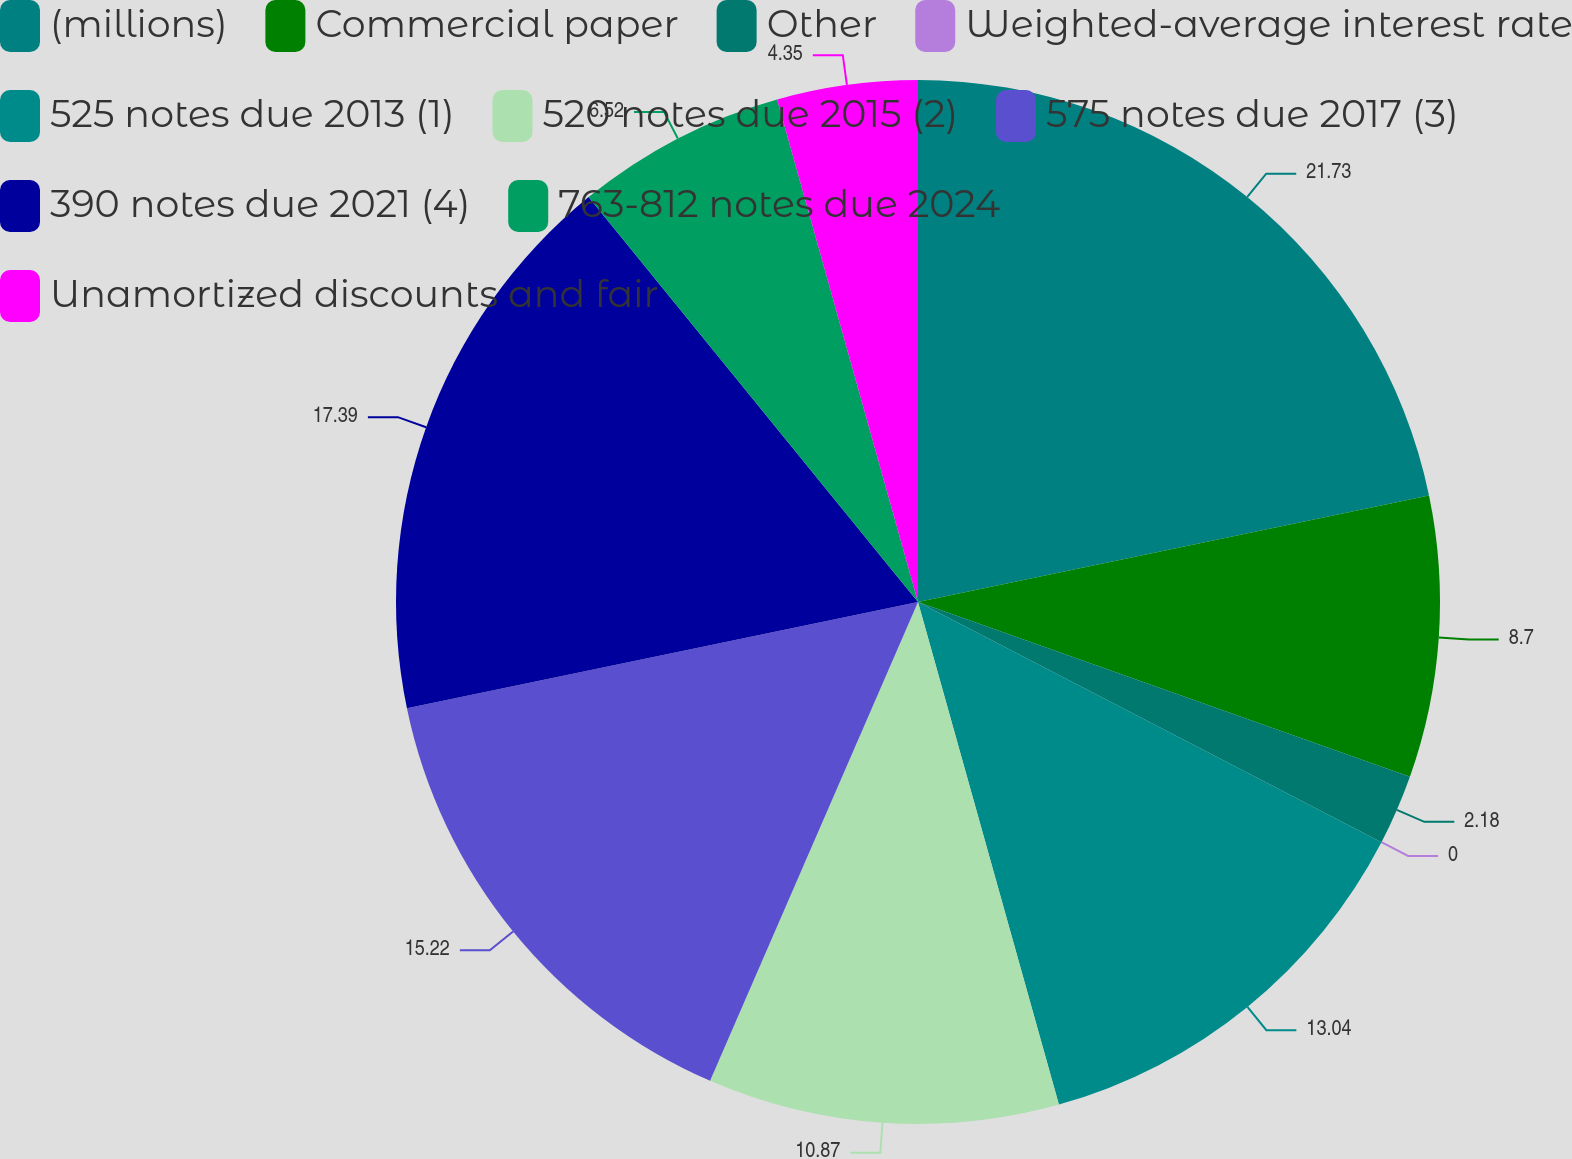<chart> <loc_0><loc_0><loc_500><loc_500><pie_chart><fcel>(millions)<fcel>Commercial paper<fcel>Other<fcel>Weighted-average interest rate<fcel>525 notes due 2013 (1)<fcel>520 notes due 2015 (2)<fcel>575 notes due 2017 (3)<fcel>390 notes due 2021 (4)<fcel>763-812 notes due 2024<fcel>Unamortized discounts and fair<nl><fcel>21.73%<fcel>8.7%<fcel>2.18%<fcel>0.0%<fcel>13.04%<fcel>10.87%<fcel>15.22%<fcel>17.39%<fcel>6.52%<fcel>4.35%<nl></chart> 